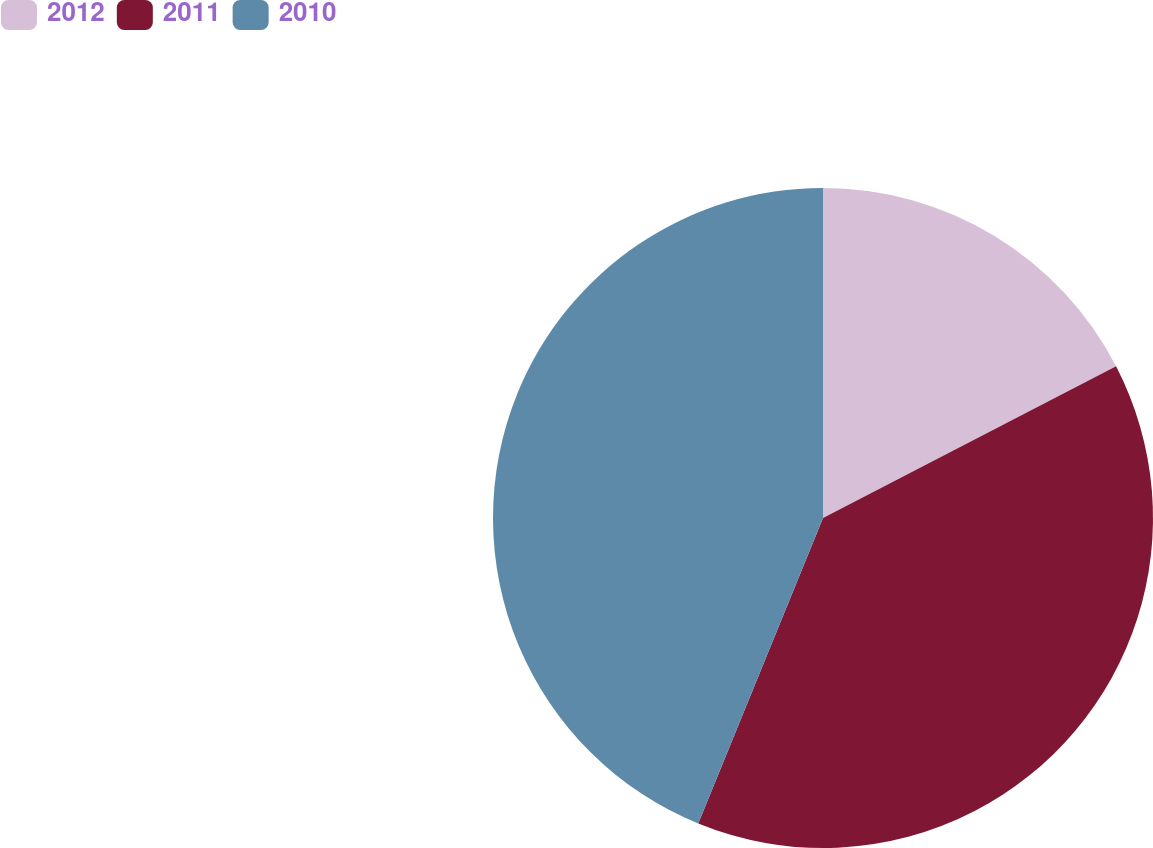Convert chart. <chart><loc_0><loc_0><loc_500><loc_500><pie_chart><fcel>2012<fcel>2011<fcel>2010<nl><fcel>17.4%<fcel>38.77%<fcel>43.83%<nl></chart> 